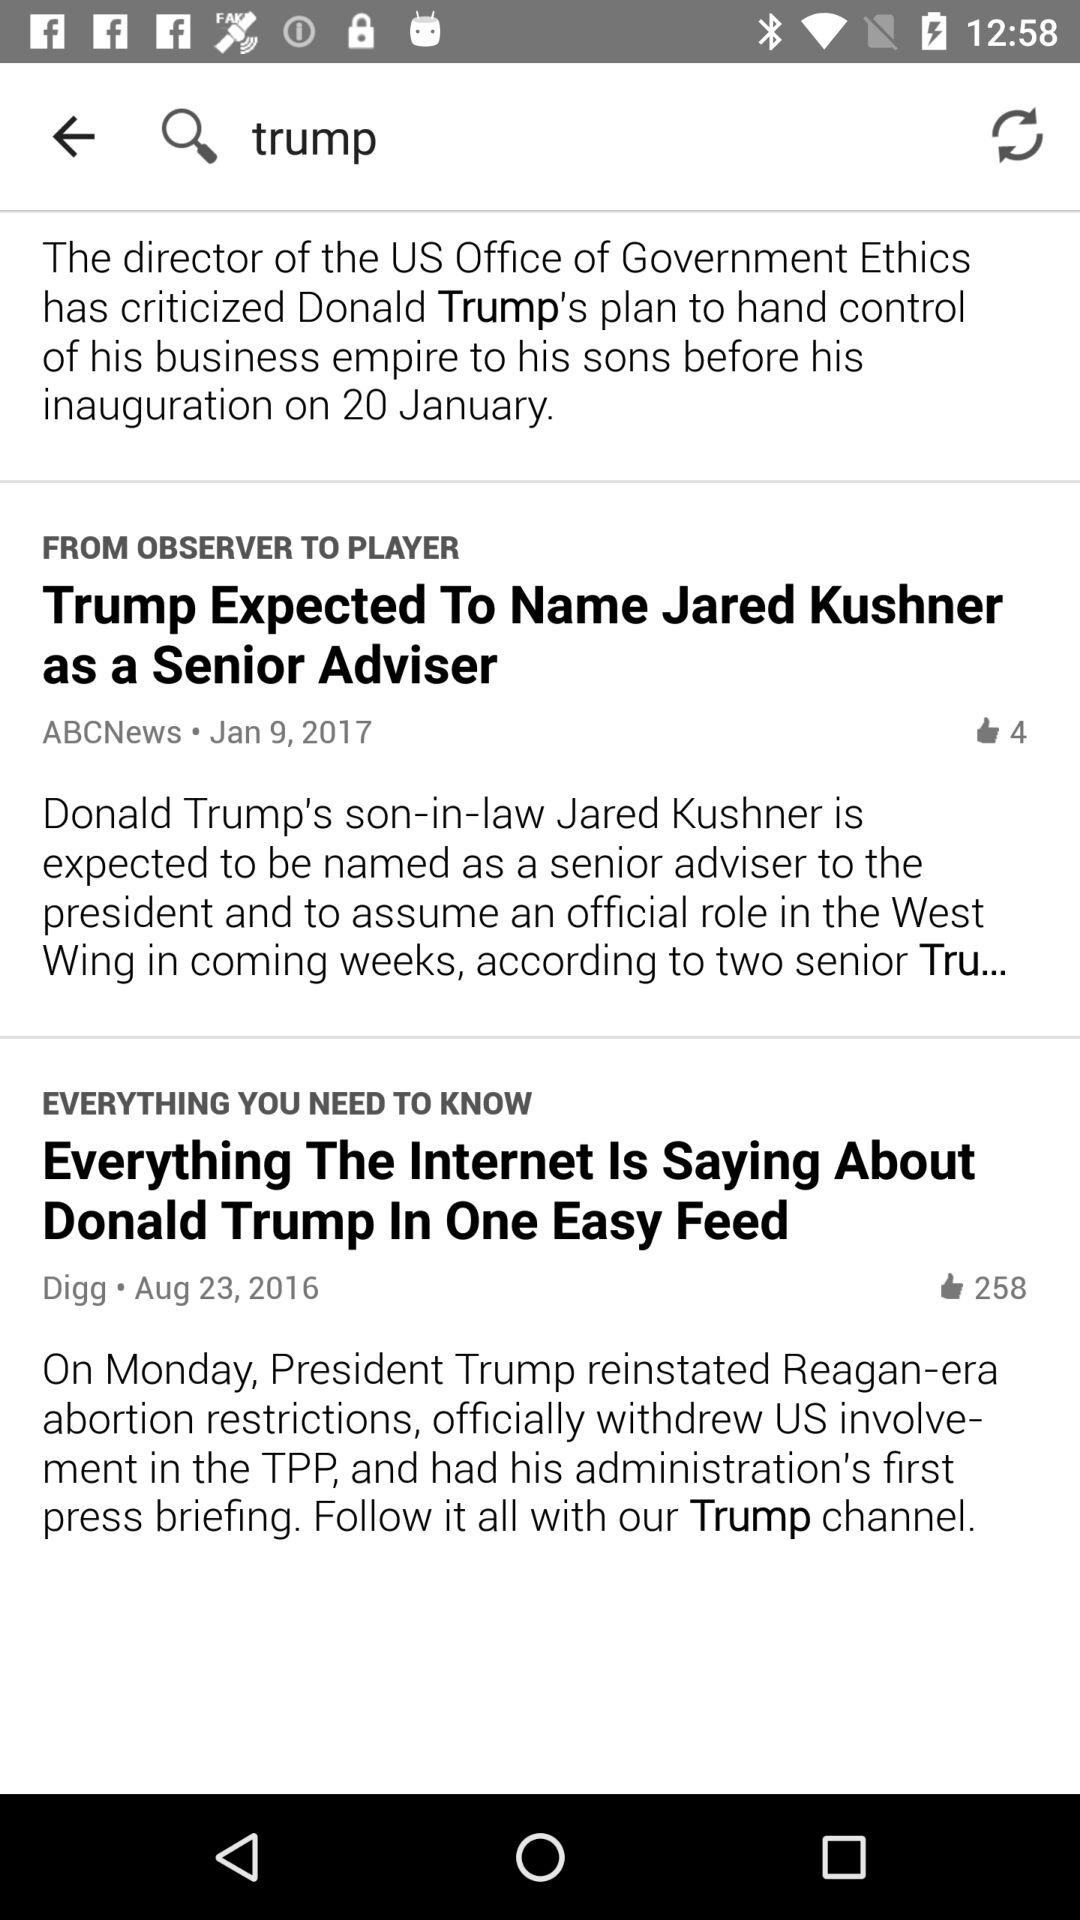How many more thumbs up does the article about Jared Kushner have than the article about Trump's business empire?
Answer the question using a single word or phrase. 254 